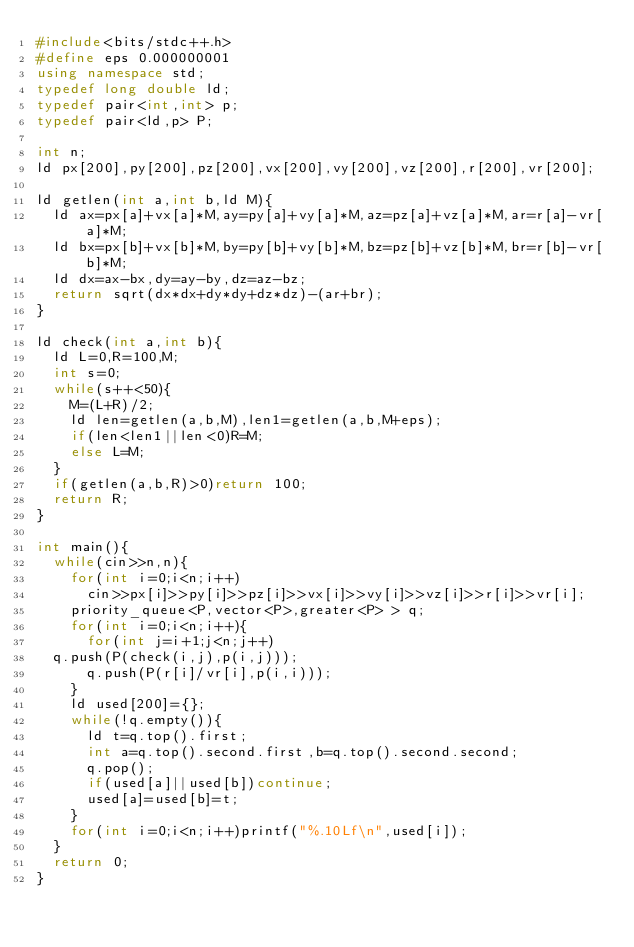<code> <loc_0><loc_0><loc_500><loc_500><_C++_>#include<bits/stdc++.h>
#define eps 0.000000001
using namespace std;
typedef long double ld;
typedef pair<int,int> p;
typedef pair<ld,p> P;

int n;
ld px[200],py[200],pz[200],vx[200],vy[200],vz[200],r[200],vr[200];

ld getlen(int a,int b,ld M){
  ld ax=px[a]+vx[a]*M,ay=py[a]+vy[a]*M,az=pz[a]+vz[a]*M,ar=r[a]-vr[a]*M;
  ld bx=px[b]+vx[b]*M,by=py[b]+vy[b]*M,bz=pz[b]+vz[b]*M,br=r[b]-vr[b]*M;
  ld dx=ax-bx,dy=ay-by,dz=az-bz;
  return sqrt(dx*dx+dy*dy+dz*dz)-(ar+br);
}

ld check(int a,int b){
  ld L=0,R=100,M;
  int s=0;
  while(s++<50){
    M=(L+R)/2;
    ld len=getlen(a,b,M),len1=getlen(a,b,M+eps);
    if(len<len1||len<0)R=M;
    else L=M;
  }
  if(getlen(a,b,R)>0)return 100;
  return R;
}

int main(){
  while(cin>>n,n){
    for(int i=0;i<n;i++)
      cin>>px[i]>>py[i]>>pz[i]>>vx[i]>>vy[i]>>vz[i]>>r[i]>>vr[i];
    priority_queue<P,vector<P>,greater<P> > q;
    for(int i=0;i<n;i++){
      for(int j=i+1;j<n;j++)
	q.push(P(check(i,j),p(i,j)));
      q.push(P(r[i]/vr[i],p(i,i)));
    }
    ld used[200]={};
    while(!q.empty()){
      ld t=q.top().first;
      int a=q.top().second.first,b=q.top().second.second;
      q.pop();
      if(used[a]||used[b])continue;
      used[a]=used[b]=t;
    }
    for(int i=0;i<n;i++)printf("%.10Lf\n",used[i]);
  }
  return 0;
}</code> 